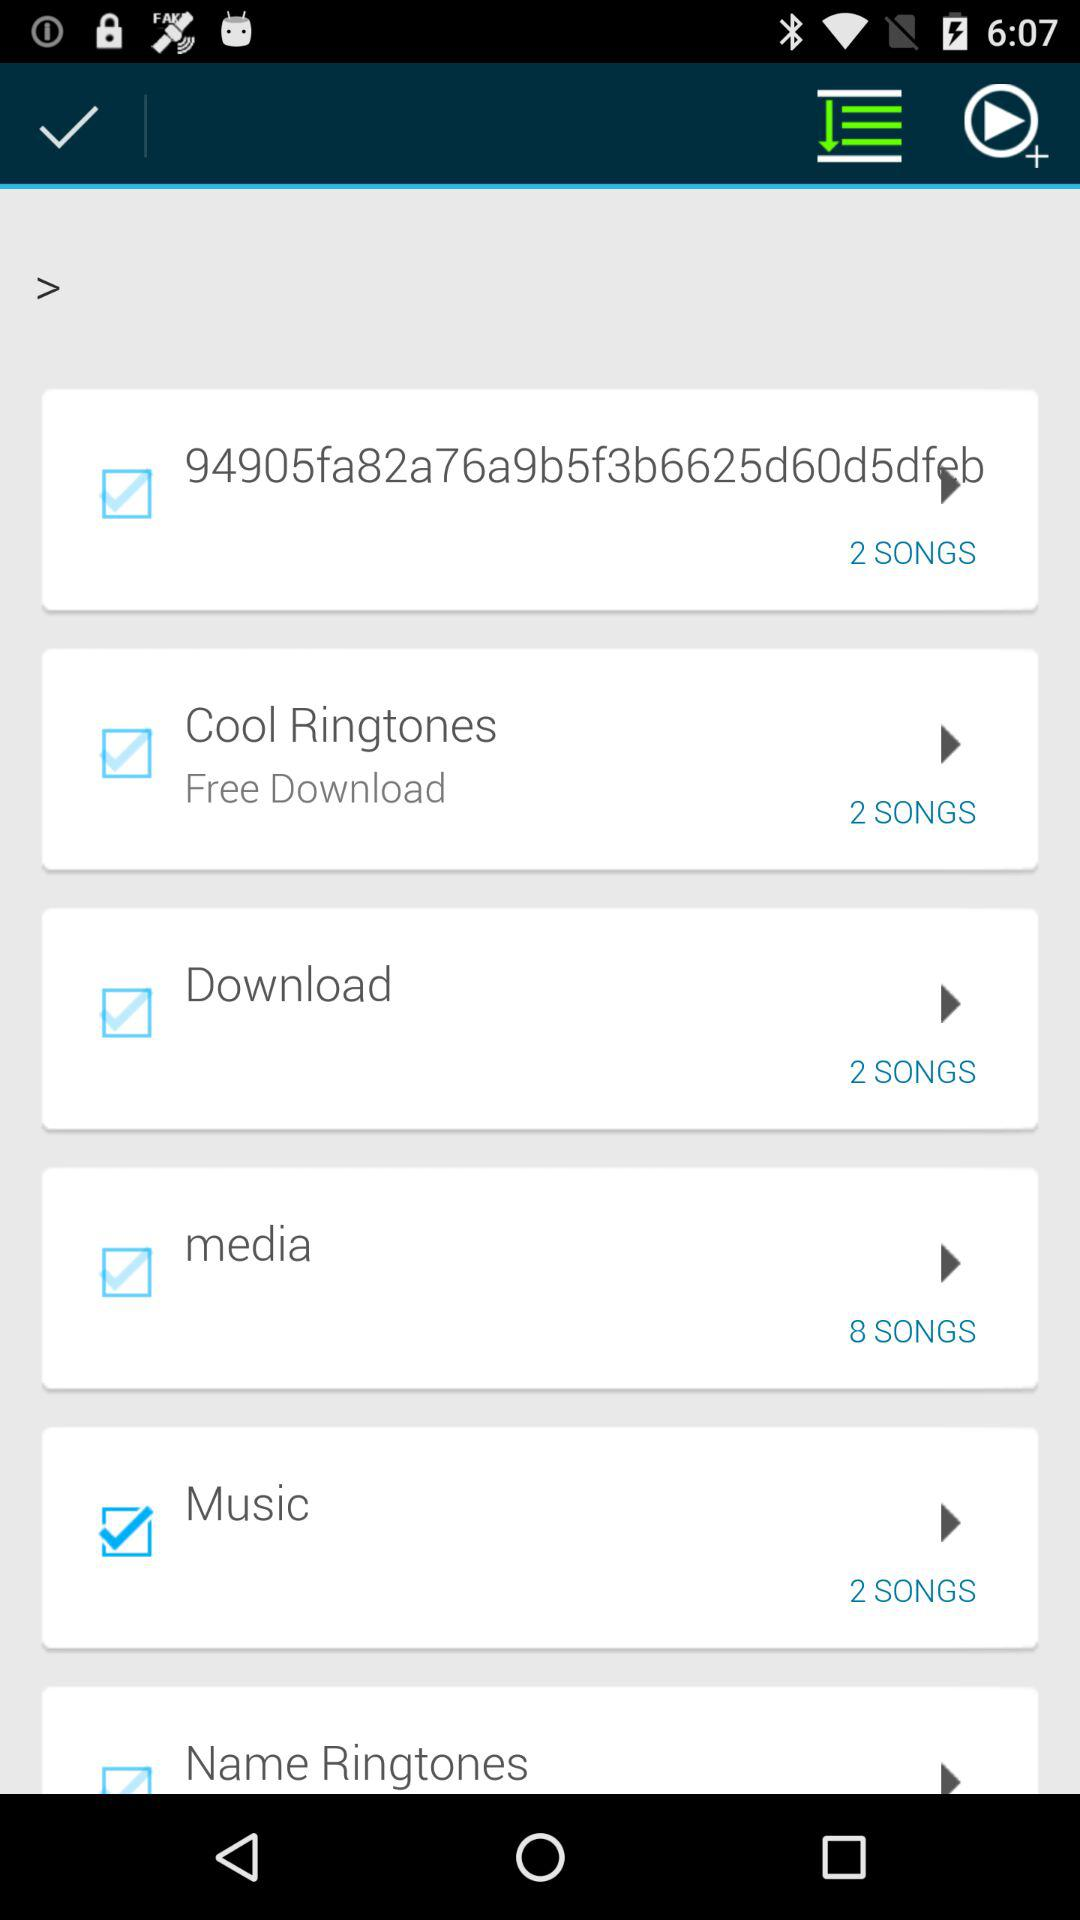What ringtones can be downloaded for free? The ringtones that can be downloaded for free are "Cool Ringtones". 